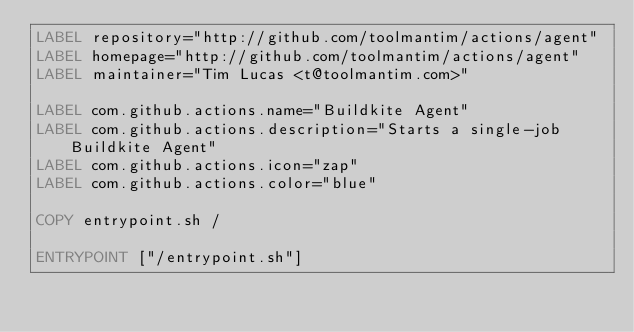Convert code to text. <code><loc_0><loc_0><loc_500><loc_500><_Dockerfile_>LABEL repository="http://github.com/toolmantim/actions/agent"
LABEL homepage="http://github.com/toolmantim/actions/agent"
LABEL maintainer="Tim Lucas <t@toolmantim.com>"

LABEL com.github.actions.name="Buildkite Agent"
LABEL com.github.actions.description="Starts a single-job Buildkite Agent"
LABEL com.github.actions.icon="zap"
LABEL com.github.actions.color="blue"

COPY entrypoint.sh /

ENTRYPOINT ["/entrypoint.sh"]</code> 